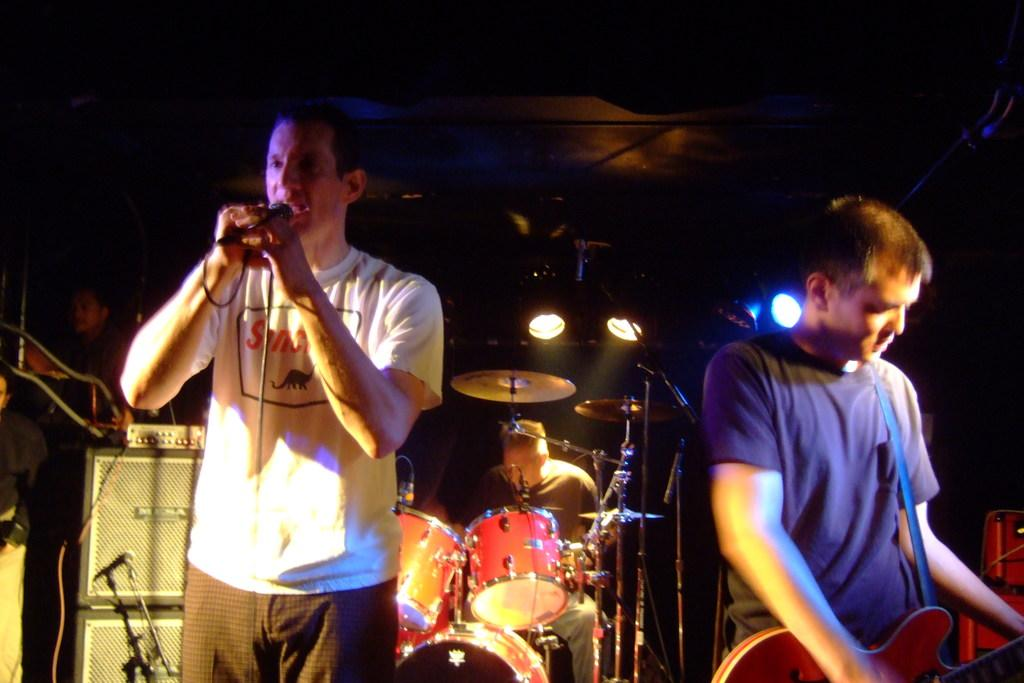What is happening in the image? There is a group of people in the image, and they are on a stage. What are the people on the stage doing? The people are playing musical instruments. What is the aftermath of the mountain in the image? There is no mountain present in the image, so it is not possible to discuss its aftermath. 